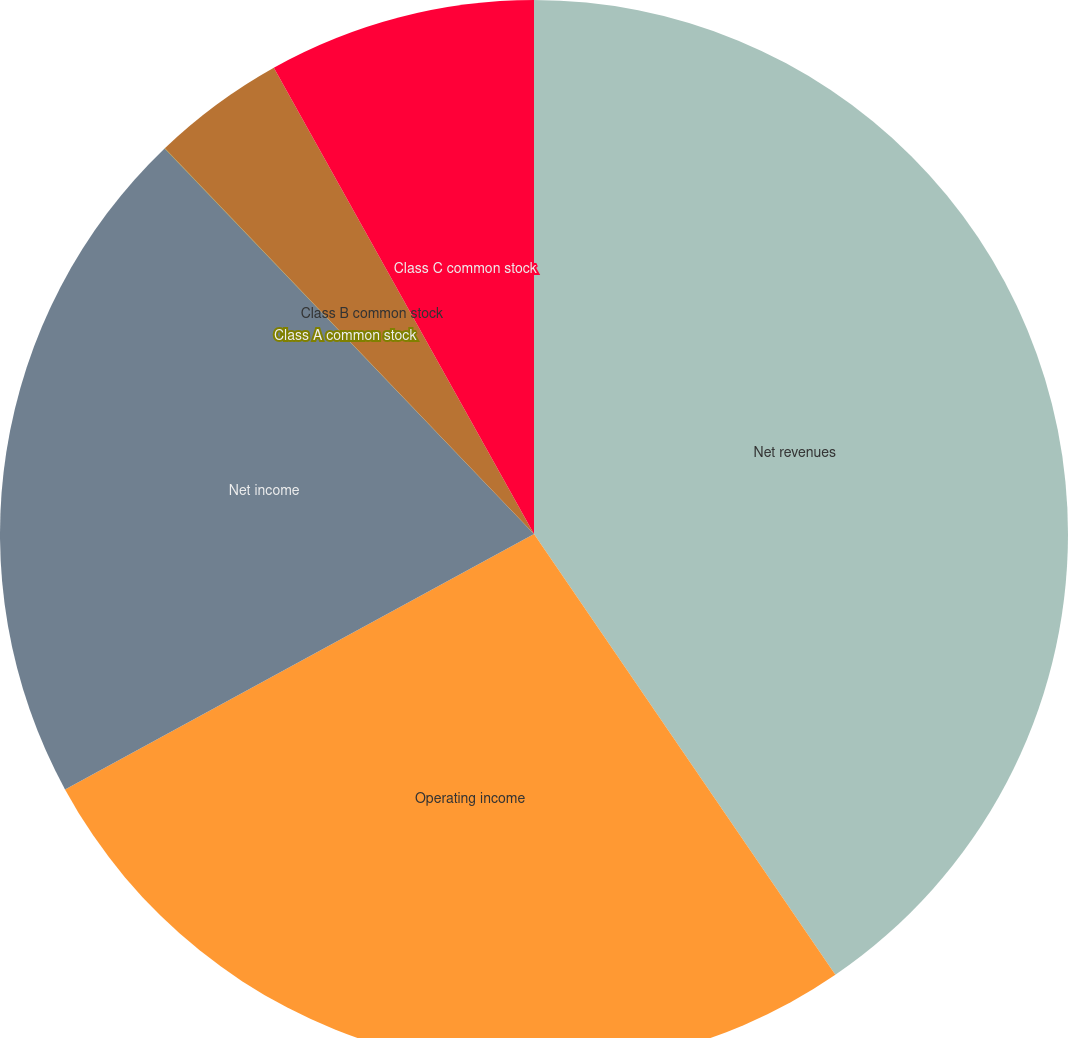Convert chart to OTSL. <chart><loc_0><loc_0><loc_500><loc_500><pie_chart><fcel>Net revenues<fcel>Operating income<fcel>Net income<fcel>Class A common stock<fcel>Class B common stock<fcel>Class C common stock<nl><fcel>40.46%<fcel>26.61%<fcel>20.78%<fcel>0.01%<fcel>4.05%<fcel>8.1%<nl></chart> 